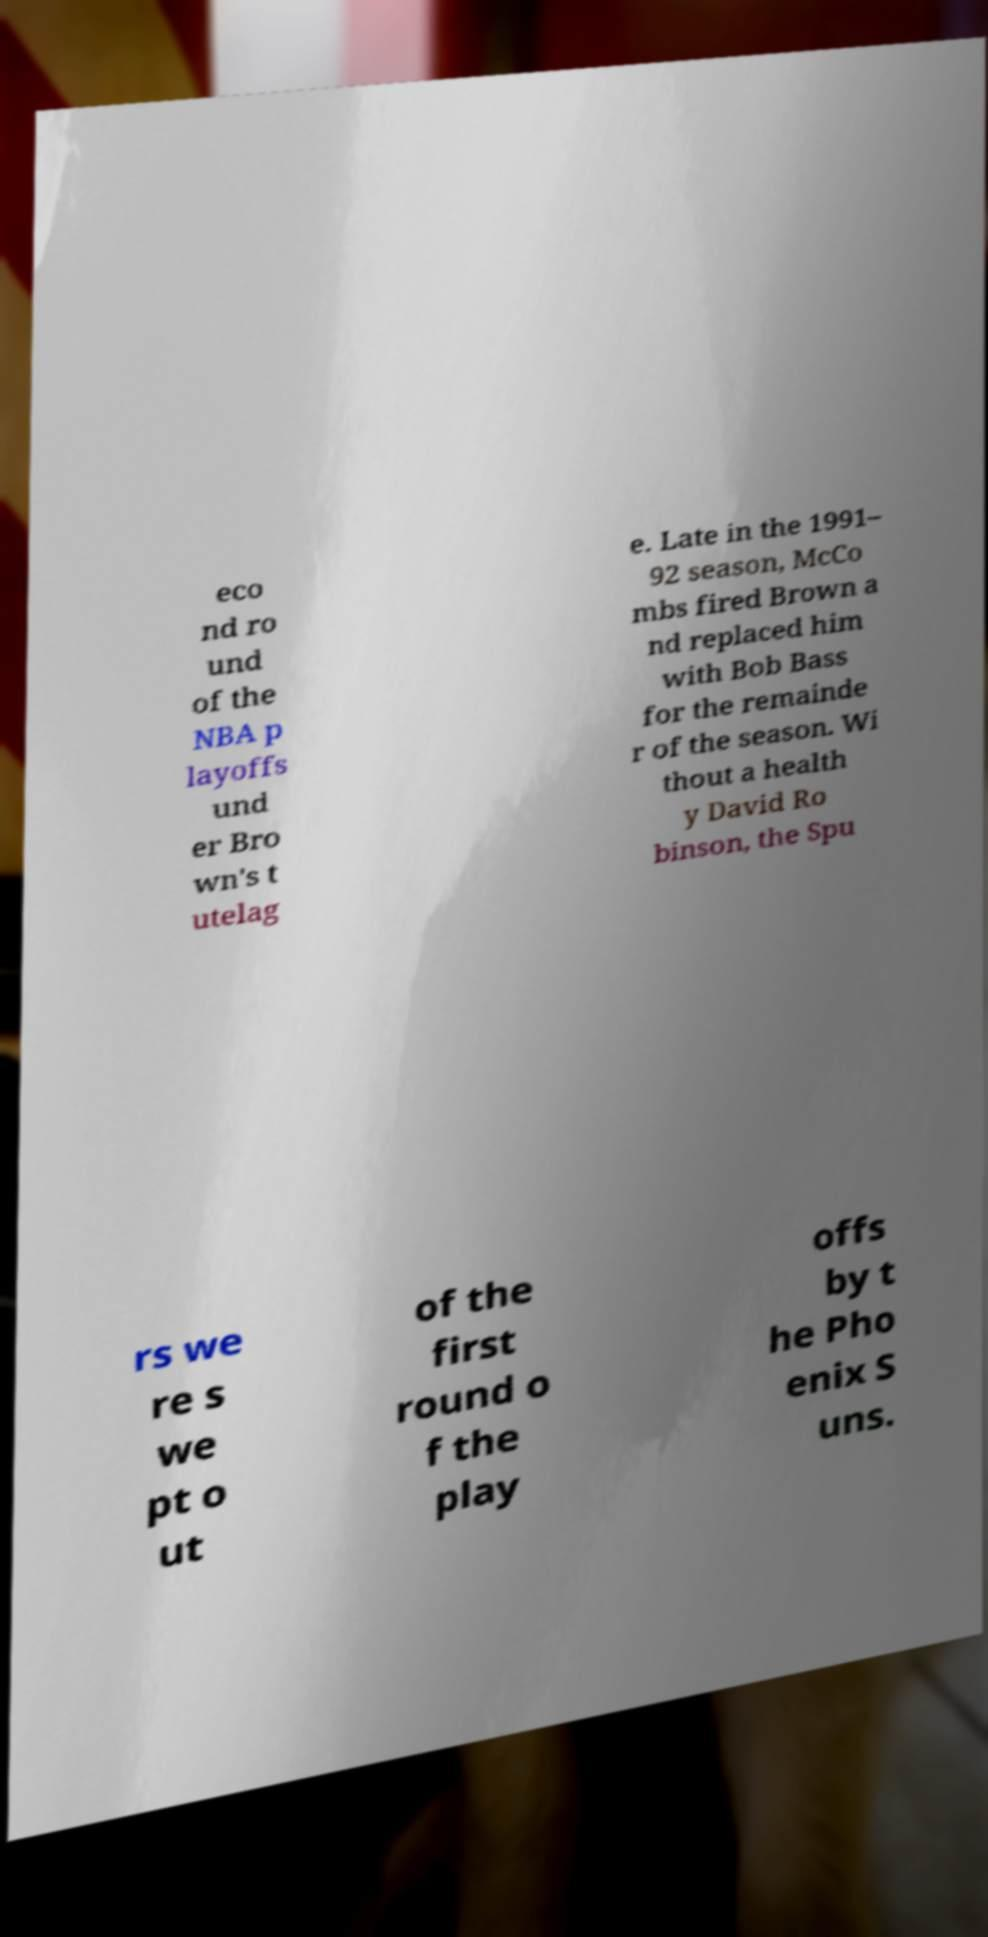What messages or text are displayed in this image? I need them in a readable, typed format. eco nd ro und of the NBA p layoffs und er Bro wn's t utelag e. Late in the 1991– 92 season, McCo mbs fired Brown a nd replaced him with Bob Bass for the remainde r of the season. Wi thout a health y David Ro binson, the Spu rs we re s we pt o ut of the first round o f the play offs by t he Pho enix S uns. 